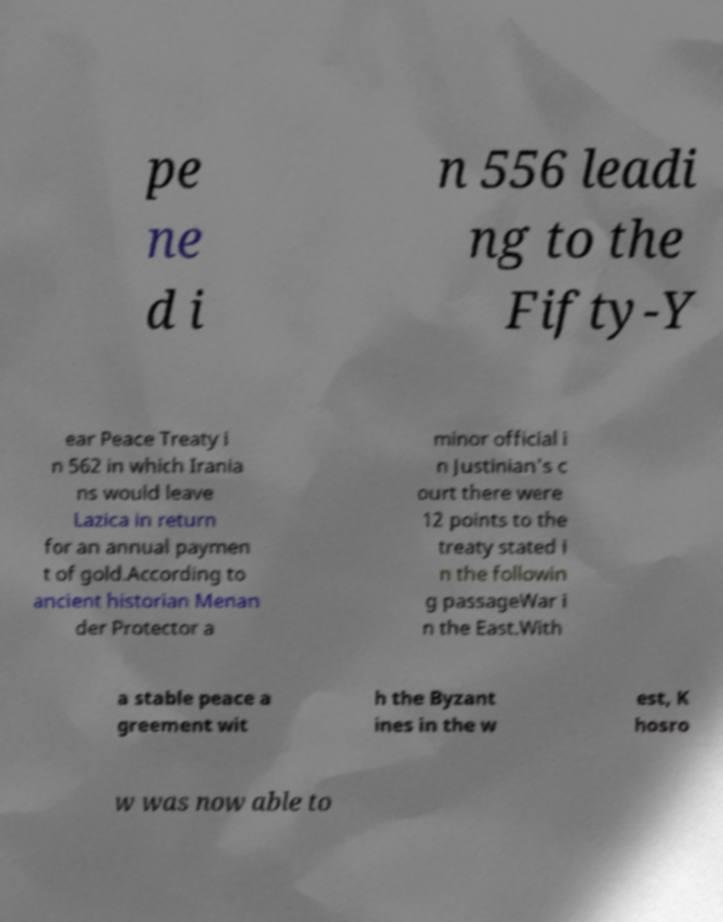What messages or text are displayed in this image? I need them in a readable, typed format. pe ne d i n 556 leadi ng to the Fifty-Y ear Peace Treaty i n 562 in which Irania ns would leave Lazica in return for an annual paymen t of gold.According to ancient historian Menan der Protector a minor official i n Justinian's c ourt there were 12 points to the treaty stated i n the followin g passageWar i n the East.With a stable peace a greement wit h the Byzant ines in the w est, K hosro w was now able to 